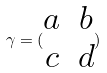<formula> <loc_0><loc_0><loc_500><loc_500>\gamma = ( \begin{matrix} a & b \\ c & d \end{matrix} )</formula> 